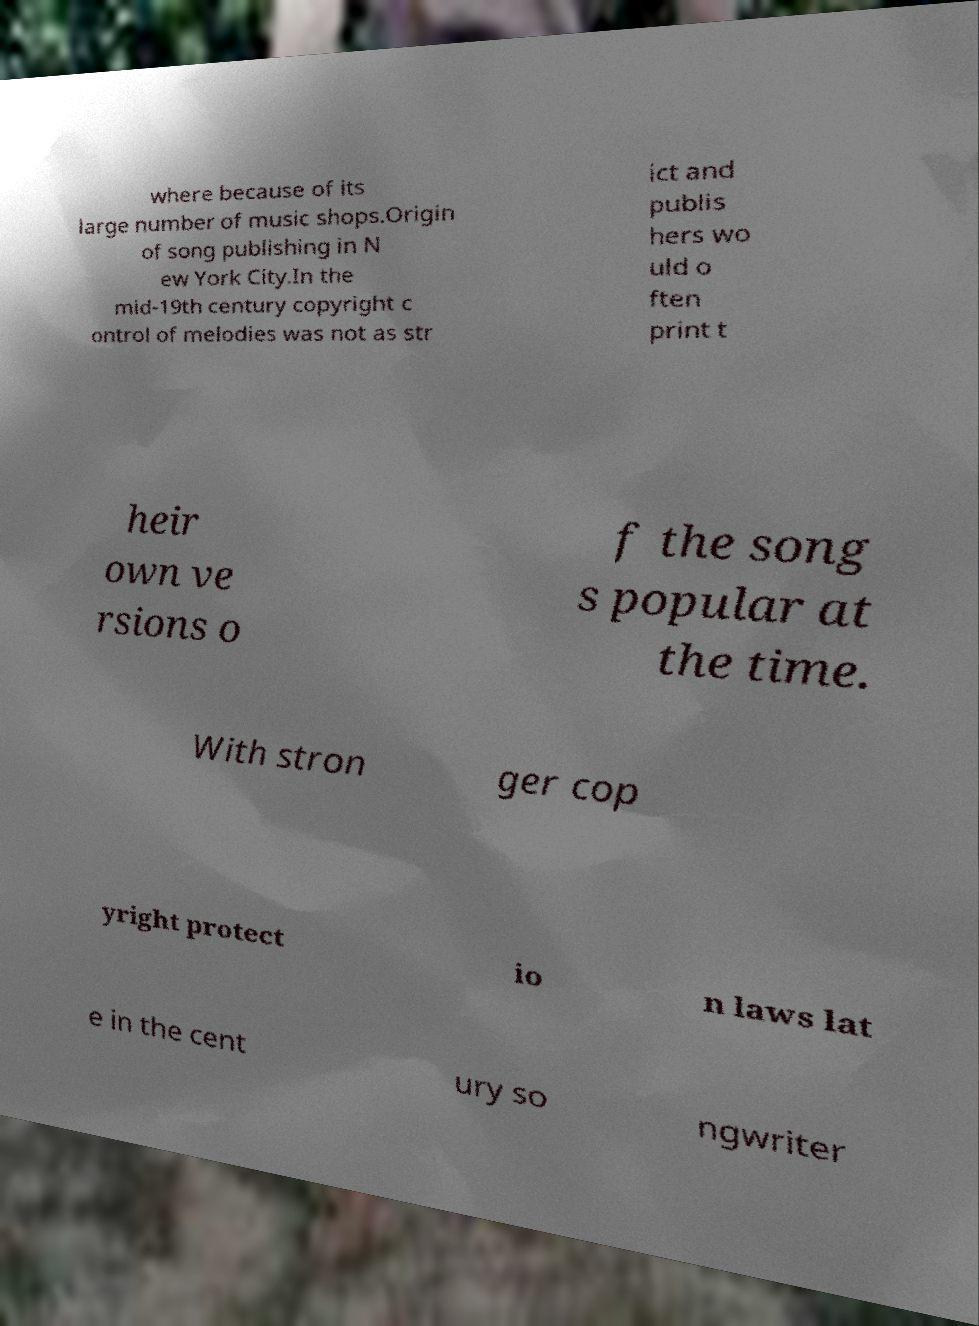Please read and relay the text visible in this image. What does it say? where because of its large number of music shops.Origin of song publishing in N ew York City.In the mid-19th century copyright c ontrol of melodies was not as str ict and publis hers wo uld o ften print t heir own ve rsions o f the song s popular at the time. With stron ger cop yright protect io n laws lat e in the cent ury so ngwriter 